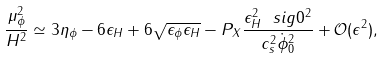<formula> <loc_0><loc_0><loc_500><loc_500>\frac { \mu _ { \phi } ^ { 2 } } { H ^ { 2 } } \simeq 3 \eta _ { \phi } - 6 \epsilon _ { H } + 6 \sqrt { \epsilon _ { \phi } \epsilon _ { H } } - P _ { X } \frac { \epsilon _ { H } ^ { 2 } \ s i g 0 ^ { 2 } } { c _ { s } ^ { 2 } \dot { \phi } ^ { 2 } _ { 0 } } + \mathcal { O } ( \epsilon ^ { 2 } ) ,</formula> 